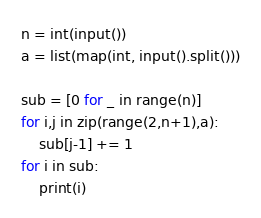<code> <loc_0><loc_0><loc_500><loc_500><_Python_>n = int(input())
a = list(map(int, input().split()))

sub = [0 for _ in range(n)]
for i,j in zip(range(2,n+1),a):
    sub[j-1] += 1
for i in sub:
    print(i)</code> 